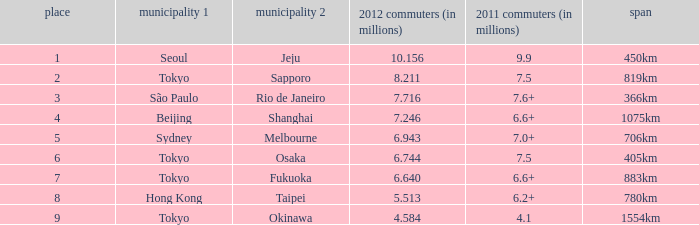Which city is listed first when Okinawa is listed as the second city? Tokyo. 